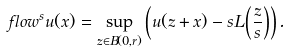Convert formula to latex. <formula><loc_0><loc_0><loc_500><loc_500>\ f l o w ^ { s } u ( x ) = \sup _ { z \in B ( 0 , r ) } \left ( u ( z + x ) - s L \left ( \frac { z } { s } \right ) \right ) .</formula> 